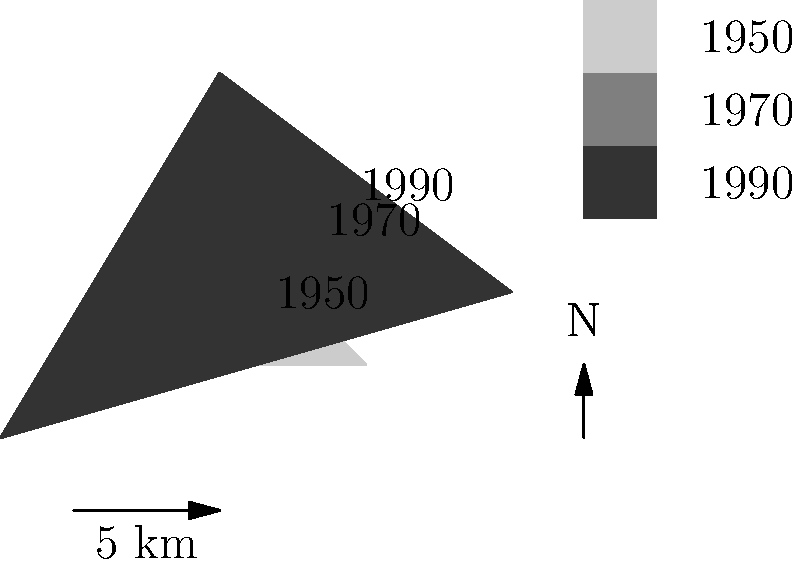Based on the city boundary expansion map shown, which decade saw the most significant increase in the city's area, and what geopolitical factors might have contributed to this growth during the Cold War era? To answer this question, we need to analyze the map and consider the historical context of the Cold War era:

1. Observe the city boundaries for each year:
   - 1950: Smallest area, represented by the lightest gray
   - 1970: Moderate increase, represented by medium gray
   - 1990: Largest area, represented by dark gray

2. Compare the expansion between decades:
   - 1950 to 1970: Moderate growth, mainly to the north and east
   - 1970 to 1990: Significant growth in all directions, particularly to the northwest and southeast

3. Identify the decade with the most significant increase:
   The period between 1970 and 1990 shows the largest expansion of city boundaries.

4. Consider Cold War era factors that might have contributed to this growth:
   a) Economic boom: Post-war economic growth and industrialization
   b) Population increase: Baby boom and migration from rural areas
   c) Suburbanization: Development of suburbs due to increased car ownership
   d) Defense industry: Expansion of military-industrial complex
   e) Urban renewal: Government-sponsored redevelopment projects
   f) Cold War tensions: Decentralization efforts to reduce vulnerability to nuclear attacks

5. Conclude that the most significant expansion occurred between 1970 and 1990, likely driven by a combination of economic growth, suburbanization, and Cold War-related factors.
Answer: 1970-1990; economic growth, suburbanization, and Cold War-related factors 